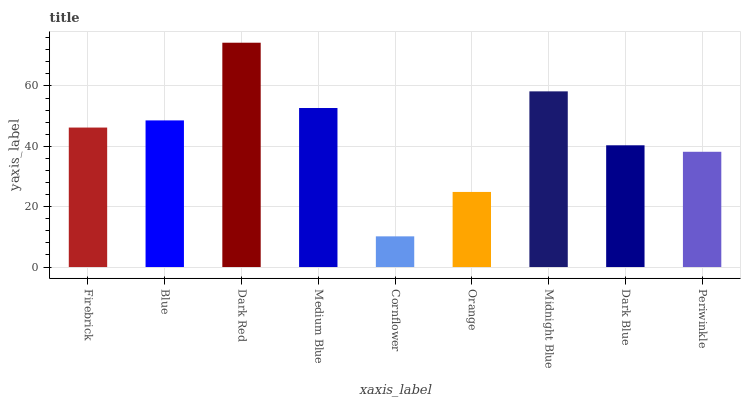Is Cornflower the minimum?
Answer yes or no. Yes. Is Dark Red the maximum?
Answer yes or no. Yes. Is Blue the minimum?
Answer yes or no. No. Is Blue the maximum?
Answer yes or no. No. Is Blue greater than Firebrick?
Answer yes or no. Yes. Is Firebrick less than Blue?
Answer yes or no. Yes. Is Firebrick greater than Blue?
Answer yes or no. No. Is Blue less than Firebrick?
Answer yes or no. No. Is Firebrick the high median?
Answer yes or no. Yes. Is Firebrick the low median?
Answer yes or no. Yes. Is Medium Blue the high median?
Answer yes or no. No. Is Midnight Blue the low median?
Answer yes or no. No. 